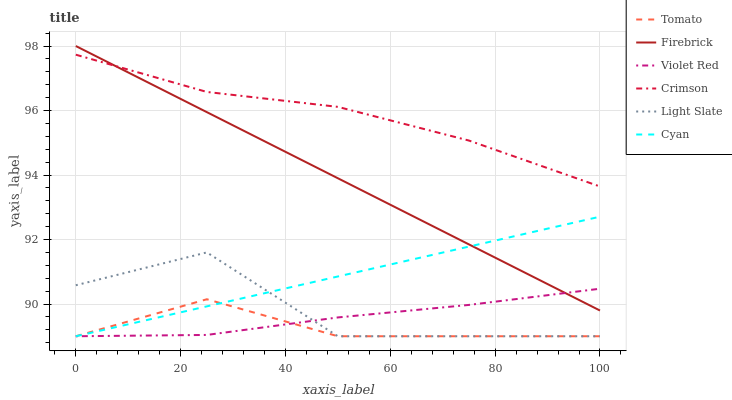Does Tomato have the minimum area under the curve?
Answer yes or no. Yes. Does Crimson have the maximum area under the curve?
Answer yes or no. Yes. Does Violet Red have the minimum area under the curve?
Answer yes or no. No. Does Violet Red have the maximum area under the curve?
Answer yes or no. No. Is Cyan the smoothest?
Answer yes or no. Yes. Is Light Slate the roughest?
Answer yes or no. Yes. Is Violet Red the smoothest?
Answer yes or no. No. Is Violet Red the roughest?
Answer yes or no. No. Does Tomato have the lowest value?
Answer yes or no. Yes. Does Firebrick have the lowest value?
Answer yes or no. No. Does Firebrick have the highest value?
Answer yes or no. Yes. Does Violet Red have the highest value?
Answer yes or no. No. Is Tomato less than Crimson?
Answer yes or no. Yes. Is Firebrick greater than Tomato?
Answer yes or no. Yes. Does Violet Red intersect Tomato?
Answer yes or no. Yes. Is Violet Red less than Tomato?
Answer yes or no. No. Is Violet Red greater than Tomato?
Answer yes or no. No. Does Tomato intersect Crimson?
Answer yes or no. No. 